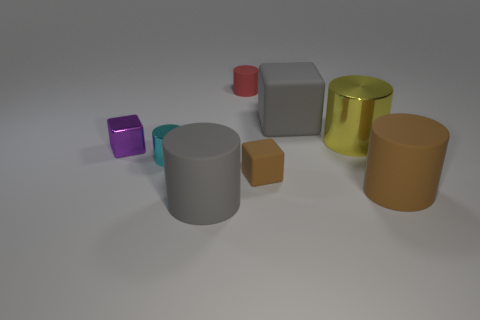Are there more yellow things than green balls?
Provide a succinct answer. Yes. Is the shiny cube the same color as the big rubber cube?
Make the answer very short. No. There is a purple cube that is the same size as the cyan metallic object; what is it made of?
Ensure brevity in your answer.  Metal. Does the brown cube have the same material as the big yellow cylinder?
Offer a very short reply. No. How many big gray objects are made of the same material as the large block?
Ensure brevity in your answer.  1. What number of objects are rubber cylinders behind the brown rubber cube or tiny rubber objects that are in front of the large metallic cylinder?
Your response must be concise. 2. Is the number of big objects in front of the yellow shiny object greater than the number of large brown things behind the gray matte cylinder?
Keep it short and to the point. Yes. There is a metal cylinder that is to the left of the tiny red cylinder; what color is it?
Give a very brief answer. Cyan. Is there a big brown object of the same shape as the tiny brown object?
Your answer should be very brief. No. What number of cyan objects are either tiny metal things or tiny matte cylinders?
Provide a short and direct response. 1. 